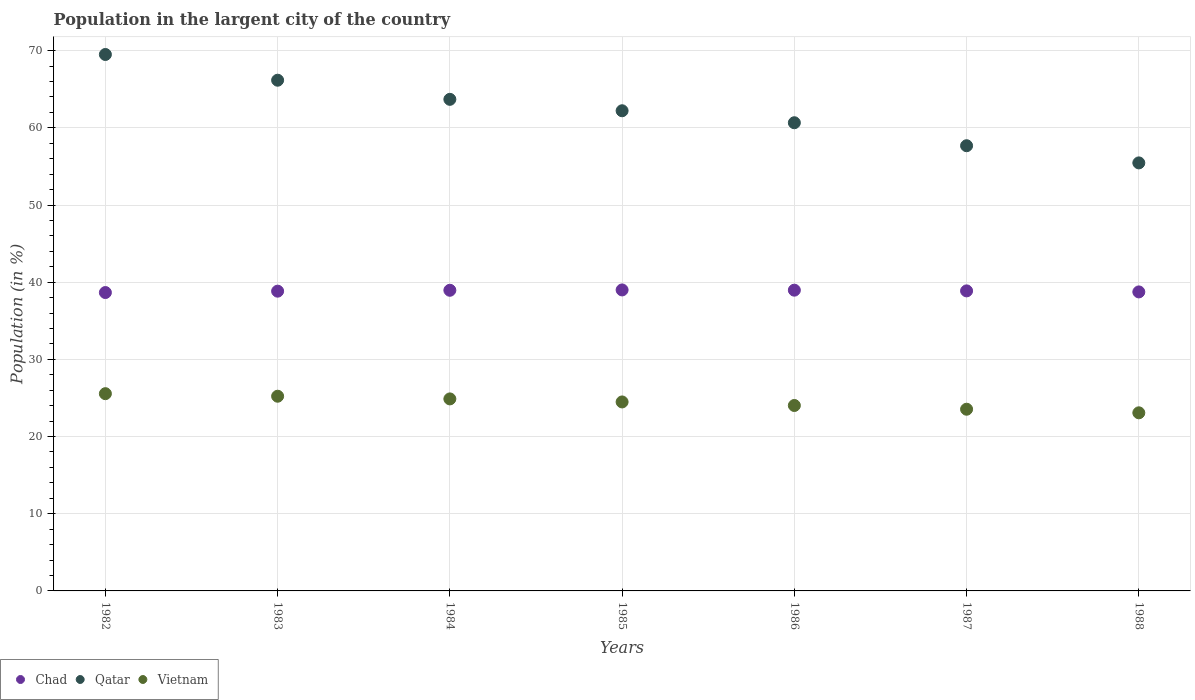Is the number of dotlines equal to the number of legend labels?
Your answer should be very brief. Yes. What is the percentage of population in the largent city in Chad in 1982?
Provide a succinct answer. 38.66. Across all years, what is the maximum percentage of population in the largent city in Vietnam?
Give a very brief answer. 25.56. Across all years, what is the minimum percentage of population in the largent city in Vietnam?
Your response must be concise. 23.08. In which year was the percentage of population in the largent city in Qatar minimum?
Offer a very short reply. 1988. What is the total percentage of population in the largent city in Chad in the graph?
Your response must be concise. 272.04. What is the difference between the percentage of population in the largent city in Qatar in 1983 and that in 1984?
Provide a succinct answer. 2.48. What is the difference between the percentage of population in the largent city in Vietnam in 1984 and the percentage of population in the largent city in Qatar in 1987?
Offer a very short reply. -32.8. What is the average percentage of population in the largent city in Chad per year?
Provide a short and direct response. 38.86. In the year 1986, what is the difference between the percentage of population in the largent city in Vietnam and percentage of population in the largent city in Qatar?
Provide a succinct answer. -36.63. What is the ratio of the percentage of population in the largent city in Vietnam in 1983 to that in 1986?
Offer a terse response. 1.05. Is the difference between the percentage of population in the largent city in Vietnam in 1985 and 1986 greater than the difference between the percentage of population in the largent city in Qatar in 1985 and 1986?
Provide a short and direct response. No. What is the difference between the highest and the second highest percentage of population in the largent city in Vietnam?
Keep it short and to the point. 0.33. What is the difference between the highest and the lowest percentage of population in the largent city in Chad?
Give a very brief answer. 0.34. Is the sum of the percentage of population in the largent city in Chad in 1985 and 1987 greater than the maximum percentage of population in the largent city in Qatar across all years?
Give a very brief answer. Yes. Is it the case that in every year, the sum of the percentage of population in the largent city in Vietnam and percentage of population in the largent city in Chad  is greater than the percentage of population in the largent city in Qatar?
Keep it short and to the point. No. Is the percentage of population in the largent city in Qatar strictly greater than the percentage of population in the largent city in Vietnam over the years?
Provide a succinct answer. Yes. How many years are there in the graph?
Your response must be concise. 7. What is the difference between two consecutive major ticks on the Y-axis?
Offer a very short reply. 10. Are the values on the major ticks of Y-axis written in scientific E-notation?
Provide a short and direct response. No. Does the graph contain any zero values?
Offer a terse response. No. Does the graph contain grids?
Keep it short and to the point. Yes. What is the title of the graph?
Keep it short and to the point. Population in the largent city of the country. What is the label or title of the X-axis?
Give a very brief answer. Years. What is the Population (in %) of Chad in 1982?
Your answer should be very brief. 38.66. What is the Population (in %) in Qatar in 1982?
Provide a succinct answer. 69.5. What is the Population (in %) in Vietnam in 1982?
Your answer should be compact. 25.56. What is the Population (in %) in Chad in 1983?
Offer a very short reply. 38.84. What is the Population (in %) in Qatar in 1983?
Your response must be concise. 66.17. What is the Population (in %) of Vietnam in 1983?
Make the answer very short. 25.23. What is the Population (in %) of Chad in 1984?
Keep it short and to the point. 38.95. What is the Population (in %) of Qatar in 1984?
Provide a short and direct response. 63.69. What is the Population (in %) in Vietnam in 1984?
Offer a very short reply. 24.88. What is the Population (in %) in Chad in 1985?
Give a very brief answer. 39. What is the Population (in %) of Qatar in 1985?
Provide a succinct answer. 62.21. What is the Population (in %) in Vietnam in 1985?
Keep it short and to the point. 24.49. What is the Population (in %) of Chad in 1986?
Your response must be concise. 38.97. What is the Population (in %) in Qatar in 1986?
Your response must be concise. 60.66. What is the Population (in %) in Vietnam in 1986?
Ensure brevity in your answer.  24.03. What is the Population (in %) of Chad in 1987?
Your answer should be compact. 38.87. What is the Population (in %) in Qatar in 1987?
Ensure brevity in your answer.  57.68. What is the Population (in %) in Vietnam in 1987?
Make the answer very short. 23.54. What is the Population (in %) in Chad in 1988?
Your answer should be very brief. 38.74. What is the Population (in %) of Qatar in 1988?
Ensure brevity in your answer.  55.46. What is the Population (in %) in Vietnam in 1988?
Give a very brief answer. 23.08. Across all years, what is the maximum Population (in %) of Chad?
Provide a short and direct response. 39. Across all years, what is the maximum Population (in %) in Qatar?
Give a very brief answer. 69.5. Across all years, what is the maximum Population (in %) of Vietnam?
Keep it short and to the point. 25.56. Across all years, what is the minimum Population (in %) of Chad?
Ensure brevity in your answer.  38.66. Across all years, what is the minimum Population (in %) in Qatar?
Make the answer very short. 55.46. Across all years, what is the minimum Population (in %) in Vietnam?
Ensure brevity in your answer.  23.08. What is the total Population (in %) of Chad in the graph?
Ensure brevity in your answer.  272.04. What is the total Population (in %) of Qatar in the graph?
Offer a terse response. 435.38. What is the total Population (in %) in Vietnam in the graph?
Your answer should be very brief. 170.79. What is the difference between the Population (in %) in Chad in 1982 and that in 1983?
Ensure brevity in your answer.  -0.18. What is the difference between the Population (in %) in Qatar in 1982 and that in 1983?
Offer a very short reply. 3.33. What is the difference between the Population (in %) of Vietnam in 1982 and that in 1983?
Make the answer very short. 0.33. What is the difference between the Population (in %) of Chad in 1982 and that in 1984?
Offer a very short reply. -0.29. What is the difference between the Population (in %) of Qatar in 1982 and that in 1984?
Make the answer very short. 5.81. What is the difference between the Population (in %) in Vietnam in 1982 and that in 1984?
Ensure brevity in your answer.  0.68. What is the difference between the Population (in %) of Chad in 1982 and that in 1985?
Keep it short and to the point. -0.34. What is the difference between the Population (in %) in Qatar in 1982 and that in 1985?
Ensure brevity in your answer.  7.29. What is the difference between the Population (in %) of Vietnam in 1982 and that in 1985?
Offer a terse response. 1.07. What is the difference between the Population (in %) of Chad in 1982 and that in 1986?
Offer a terse response. -0.31. What is the difference between the Population (in %) in Qatar in 1982 and that in 1986?
Your response must be concise. 8.84. What is the difference between the Population (in %) of Vietnam in 1982 and that in 1986?
Your answer should be very brief. 1.53. What is the difference between the Population (in %) of Chad in 1982 and that in 1987?
Provide a succinct answer. -0.22. What is the difference between the Population (in %) in Qatar in 1982 and that in 1987?
Provide a succinct answer. 11.82. What is the difference between the Population (in %) of Vietnam in 1982 and that in 1987?
Ensure brevity in your answer.  2.01. What is the difference between the Population (in %) in Chad in 1982 and that in 1988?
Provide a succinct answer. -0.08. What is the difference between the Population (in %) in Qatar in 1982 and that in 1988?
Provide a succinct answer. 14.05. What is the difference between the Population (in %) in Vietnam in 1982 and that in 1988?
Your response must be concise. 2.48. What is the difference between the Population (in %) in Chad in 1983 and that in 1984?
Offer a terse response. -0.12. What is the difference between the Population (in %) of Qatar in 1983 and that in 1984?
Offer a very short reply. 2.48. What is the difference between the Population (in %) of Vietnam in 1983 and that in 1984?
Your response must be concise. 0.35. What is the difference between the Population (in %) in Chad in 1983 and that in 1985?
Your answer should be compact. -0.16. What is the difference between the Population (in %) of Qatar in 1983 and that in 1985?
Keep it short and to the point. 3.96. What is the difference between the Population (in %) of Vietnam in 1983 and that in 1985?
Ensure brevity in your answer.  0.74. What is the difference between the Population (in %) of Chad in 1983 and that in 1986?
Provide a short and direct response. -0.13. What is the difference between the Population (in %) of Qatar in 1983 and that in 1986?
Your answer should be compact. 5.51. What is the difference between the Population (in %) of Vietnam in 1983 and that in 1986?
Offer a very short reply. 1.2. What is the difference between the Population (in %) in Chad in 1983 and that in 1987?
Provide a short and direct response. -0.04. What is the difference between the Population (in %) in Qatar in 1983 and that in 1987?
Your answer should be very brief. 8.49. What is the difference between the Population (in %) in Vietnam in 1983 and that in 1987?
Your response must be concise. 1.68. What is the difference between the Population (in %) of Chad in 1983 and that in 1988?
Your answer should be very brief. 0.1. What is the difference between the Population (in %) of Qatar in 1983 and that in 1988?
Provide a short and direct response. 10.71. What is the difference between the Population (in %) in Vietnam in 1983 and that in 1988?
Provide a short and direct response. 2.15. What is the difference between the Population (in %) in Chad in 1984 and that in 1985?
Your answer should be compact. -0.04. What is the difference between the Population (in %) in Qatar in 1984 and that in 1985?
Ensure brevity in your answer.  1.48. What is the difference between the Population (in %) of Vietnam in 1984 and that in 1985?
Your answer should be compact. 0.39. What is the difference between the Population (in %) in Chad in 1984 and that in 1986?
Your answer should be very brief. -0.01. What is the difference between the Population (in %) of Qatar in 1984 and that in 1986?
Offer a very short reply. 3.03. What is the difference between the Population (in %) in Vietnam in 1984 and that in 1986?
Offer a terse response. 0.85. What is the difference between the Population (in %) in Chad in 1984 and that in 1987?
Offer a very short reply. 0.08. What is the difference between the Population (in %) of Qatar in 1984 and that in 1987?
Give a very brief answer. 6.01. What is the difference between the Population (in %) in Vietnam in 1984 and that in 1987?
Keep it short and to the point. 1.34. What is the difference between the Population (in %) in Chad in 1984 and that in 1988?
Provide a short and direct response. 0.21. What is the difference between the Population (in %) of Qatar in 1984 and that in 1988?
Your answer should be very brief. 8.23. What is the difference between the Population (in %) in Vietnam in 1984 and that in 1988?
Ensure brevity in your answer.  1.8. What is the difference between the Population (in %) of Chad in 1985 and that in 1986?
Keep it short and to the point. 0.03. What is the difference between the Population (in %) in Qatar in 1985 and that in 1986?
Offer a terse response. 1.55. What is the difference between the Population (in %) of Vietnam in 1985 and that in 1986?
Your answer should be compact. 0.46. What is the difference between the Population (in %) of Chad in 1985 and that in 1987?
Give a very brief answer. 0.12. What is the difference between the Population (in %) of Qatar in 1985 and that in 1987?
Provide a short and direct response. 4.53. What is the difference between the Population (in %) of Vietnam in 1985 and that in 1987?
Give a very brief answer. 0.94. What is the difference between the Population (in %) of Chad in 1985 and that in 1988?
Ensure brevity in your answer.  0.26. What is the difference between the Population (in %) in Qatar in 1985 and that in 1988?
Your answer should be very brief. 6.75. What is the difference between the Population (in %) in Vietnam in 1985 and that in 1988?
Your answer should be compact. 1.41. What is the difference between the Population (in %) of Chad in 1986 and that in 1987?
Provide a succinct answer. 0.09. What is the difference between the Population (in %) in Qatar in 1986 and that in 1987?
Ensure brevity in your answer.  2.98. What is the difference between the Population (in %) in Vietnam in 1986 and that in 1987?
Offer a very short reply. 0.48. What is the difference between the Population (in %) of Chad in 1986 and that in 1988?
Offer a terse response. 0.23. What is the difference between the Population (in %) in Qatar in 1986 and that in 1988?
Your answer should be very brief. 5.2. What is the difference between the Population (in %) of Vietnam in 1986 and that in 1988?
Offer a terse response. 0.95. What is the difference between the Population (in %) in Chad in 1987 and that in 1988?
Provide a succinct answer. 0.13. What is the difference between the Population (in %) in Qatar in 1987 and that in 1988?
Your response must be concise. 2.22. What is the difference between the Population (in %) in Vietnam in 1987 and that in 1988?
Your response must be concise. 0.47. What is the difference between the Population (in %) of Chad in 1982 and the Population (in %) of Qatar in 1983?
Provide a succinct answer. -27.51. What is the difference between the Population (in %) in Chad in 1982 and the Population (in %) in Vietnam in 1983?
Give a very brief answer. 13.43. What is the difference between the Population (in %) in Qatar in 1982 and the Population (in %) in Vietnam in 1983?
Provide a succinct answer. 44.28. What is the difference between the Population (in %) of Chad in 1982 and the Population (in %) of Qatar in 1984?
Your answer should be compact. -25.03. What is the difference between the Population (in %) of Chad in 1982 and the Population (in %) of Vietnam in 1984?
Your response must be concise. 13.78. What is the difference between the Population (in %) of Qatar in 1982 and the Population (in %) of Vietnam in 1984?
Provide a short and direct response. 44.62. What is the difference between the Population (in %) in Chad in 1982 and the Population (in %) in Qatar in 1985?
Offer a very short reply. -23.55. What is the difference between the Population (in %) of Chad in 1982 and the Population (in %) of Vietnam in 1985?
Keep it short and to the point. 14.17. What is the difference between the Population (in %) of Qatar in 1982 and the Population (in %) of Vietnam in 1985?
Provide a short and direct response. 45.02. What is the difference between the Population (in %) in Chad in 1982 and the Population (in %) in Qatar in 1986?
Keep it short and to the point. -22. What is the difference between the Population (in %) of Chad in 1982 and the Population (in %) of Vietnam in 1986?
Offer a very short reply. 14.63. What is the difference between the Population (in %) of Qatar in 1982 and the Population (in %) of Vietnam in 1986?
Make the answer very short. 45.48. What is the difference between the Population (in %) in Chad in 1982 and the Population (in %) in Qatar in 1987?
Make the answer very short. -19.02. What is the difference between the Population (in %) in Chad in 1982 and the Population (in %) in Vietnam in 1987?
Provide a short and direct response. 15.12. What is the difference between the Population (in %) of Qatar in 1982 and the Population (in %) of Vietnam in 1987?
Provide a short and direct response. 45.96. What is the difference between the Population (in %) in Chad in 1982 and the Population (in %) in Qatar in 1988?
Provide a short and direct response. -16.8. What is the difference between the Population (in %) in Chad in 1982 and the Population (in %) in Vietnam in 1988?
Offer a terse response. 15.58. What is the difference between the Population (in %) in Qatar in 1982 and the Population (in %) in Vietnam in 1988?
Your response must be concise. 46.43. What is the difference between the Population (in %) of Chad in 1983 and the Population (in %) of Qatar in 1984?
Offer a terse response. -24.85. What is the difference between the Population (in %) in Chad in 1983 and the Population (in %) in Vietnam in 1984?
Your answer should be very brief. 13.96. What is the difference between the Population (in %) in Qatar in 1983 and the Population (in %) in Vietnam in 1984?
Offer a terse response. 41.29. What is the difference between the Population (in %) of Chad in 1983 and the Population (in %) of Qatar in 1985?
Offer a terse response. -23.37. What is the difference between the Population (in %) in Chad in 1983 and the Population (in %) in Vietnam in 1985?
Make the answer very short. 14.35. What is the difference between the Population (in %) in Qatar in 1983 and the Population (in %) in Vietnam in 1985?
Provide a short and direct response. 41.68. What is the difference between the Population (in %) in Chad in 1983 and the Population (in %) in Qatar in 1986?
Offer a terse response. -21.82. What is the difference between the Population (in %) of Chad in 1983 and the Population (in %) of Vietnam in 1986?
Your answer should be compact. 14.81. What is the difference between the Population (in %) in Qatar in 1983 and the Population (in %) in Vietnam in 1986?
Provide a succinct answer. 42.14. What is the difference between the Population (in %) of Chad in 1983 and the Population (in %) of Qatar in 1987?
Your answer should be compact. -18.84. What is the difference between the Population (in %) of Chad in 1983 and the Population (in %) of Vietnam in 1987?
Provide a succinct answer. 15.3. What is the difference between the Population (in %) of Qatar in 1983 and the Population (in %) of Vietnam in 1987?
Provide a short and direct response. 42.63. What is the difference between the Population (in %) of Chad in 1983 and the Population (in %) of Qatar in 1988?
Offer a terse response. -16.62. What is the difference between the Population (in %) of Chad in 1983 and the Population (in %) of Vietnam in 1988?
Offer a terse response. 15.76. What is the difference between the Population (in %) in Qatar in 1983 and the Population (in %) in Vietnam in 1988?
Provide a succinct answer. 43.09. What is the difference between the Population (in %) in Chad in 1984 and the Population (in %) in Qatar in 1985?
Your response must be concise. -23.26. What is the difference between the Population (in %) of Chad in 1984 and the Population (in %) of Vietnam in 1985?
Offer a very short reply. 14.47. What is the difference between the Population (in %) in Qatar in 1984 and the Population (in %) in Vietnam in 1985?
Provide a succinct answer. 39.21. What is the difference between the Population (in %) in Chad in 1984 and the Population (in %) in Qatar in 1986?
Your answer should be compact. -21.71. What is the difference between the Population (in %) in Chad in 1984 and the Population (in %) in Vietnam in 1986?
Your response must be concise. 14.93. What is the difference between the Population (in %) of Qatar in 1984 and the Population (in %) of Vietnam in 1986?
Your answer should be compact. 39.67. What is the difference between the Population (in %) of Chad in 1984 and the Population (in %) of Qatar in 1987?
Your response must be concise. -18.73. What is the difference between the Population (in %) in Chad in 1984 and the Population (in %) in Vietnam in 1987?
Offer a very short reply. 15.41. What is the difference between the Population (in %) in Qatar in 1984 and the Population (in %) in Vietnam in 1987?
Your answer should be very brief. 40.15. What is the difference between the Population (in %) of Chad in 1984 and the Population (in %) of Qatar in 1988?
Your answer should be compact. -16.5. What is the difference between the Population (in %) of Chad in 1984 and the Population (in %) of Vietnam in 1988?
Provide a succinct answer. 15.88. What is the difference between the Population (in %) of Qatar in 1984 and the Population (in %) of Vietnam in 1988?
Keep it short and to the point. 40.62. What is the difference between the Population (in %) in Chad in 1985 and the Population (in %) in Qatar in 1986?
Your answer should be compact. -21.66. What is the difference between the Population (in %) of Chad in 1985 and the Population (in %) of Vietnam in 1986?
Your answer should be very brief. 14.97. What is the difference between the Population (in %) in Qatar in 1985 and the Population (in %) in Vietnam in 1986?
Ensure brevity in your answer.  38.19. What is the difference between the Population (in %) in Chad in 1985 and the Population (in %) in Qatar in 1987?
Keep it short and to the point. -18.68. What is the difference between the Population (in %) of Chad in 1985 and the Population (in %) of Vietnam in 1987?
Offer a very short reply. 15.46. What is the difference between the Population (in %) in Qatar in 1985 and the Population (in %) in Vietnam in 1987?
Your answer should be very brief. 38.67. What is the difference between the Population (in %) of Chad in 1985 and the Population (in %) of Qatar in 1988?
Provide a succinct answer. -16.46. What is the difference between the Population (in %) of Chad in 1985 and the Population (in %) of Vietnam in 1988?
Provide a succinct answer. 15.92. What is the difference between the Population (in %) in Qatar in 1985 and the Population (in %) in Vietnam in 1988?
Provide a short and direct response. 39.14. What is the difference between the Population (in %) in Chad in 1986 and the Population (in %) in Qatar in 1987?
Provide a succinct answer. -18.71. What is the difference between the Population (in %) of Chad in 1986 and the Population (in %) of Vietnam in 1987?
Your response must be concise. 15.43. What is the difference between the Population (in %) in Qatar in 1986 and the Population (in %) in Vietnam in 1987?
Make the answer very short. 37.12. What is the difference between the Population (in %) of Chad in 1986 and the Population (in %) of Qatar in 1988?
Give a very brief answer. -16.49. What is the difference between the Population (in %) in Chad in 1986 and the Population (in %) in Vietnam in 1988?
Your answer should be very brief. 15.89. What is the difference between the Population (in %) of Qatar in 1986 and the Population (in %) of Vietnam in 1988?
Your response must be concise. 37.58. What is the difference between the Population (in %) of Chad in 1987 and the Population (in %) of Qatar in 1988?
Make the answer very short. -16.58. What is the difference between the Population (in %) in Chad in 1987 and the Population (in %) in Vietnam in 1988?
Make the answer very short. 15.8. What is the difference between the Population (in %) in Qatar in 1987 and the Population (in %) in Vietnam in 1988?
Give a very brief answer. 34.61. What is the average Population (in %) of Chad per year?
Make the answer very short. 38.86. What is the average Population (in %) in Qatar per year?
Offer a very short reply. 62.2. What is the average Population (in %) in Vietnam per year?
Make the answer very short. 24.4. In the year 1982, what is the difference between the Population (in %) of Chad and Population (in %) of Qatar?
Your response must be concise. -30.84. In the year 1982, what is the difference between the Population (in %) of Chad and Population (in %) of Vietnam?
Your response must be concise. 13.1. In the year 1982, what is the difference between the Population (in %) in Qatar and Population (in %) in Vietnam?
Keep it short and to the point. 43.95. In the year 1983, what is the difference between the Population (in %) in Chad and Population (in %) in Qatar?
Your response must be concise. -27.33. In the year 1983, what is the difference between the Population (in %) of Chad and Population (in %) of Vietnam?
Make the answer very short. 13.61. In the year 1983, what is the difference between the Population (in %) of Qatar and Population (in %) of Vietnam?
Offer a very short reply. 40.94. In the year 1984, what is the difference between the Population (in %) of Chad and Population (in %) of Qatar?
Ensure brevity in your answer.  -24.74. In the year 1984, what is the difference between the Population (in %) of Chad and Population (in %) of Vietnam?
Give a very brief answer. 14.08. In the year 1984, what is the difference between the Population (in %) in Qatar and Population (in %) in Vietnam?
Offer a terse response. 38.81. In the year 1985, what is the difference between the Population (in %) of Chad and Population (in %) of Qatar?
Ensure brevity in your answer.  -23.21. In the year 1985, what is the difference between the Population (in %) of Chad and Population (in %) of Vietnam?
Ensure brevity in your answer.  14.51. In the year 1985, what is the difference between the Population (in %) of Qatar and Population (in %) of Vietnam?
Ensure brevity in your answer.  37.73. In the year 1986, what is the difference between the Population (in %) of Chad and Population (in %) of Qatar?
Give a very brief answer. -21.69. In the year 1986, what is the difference between the Population (in %) of Chad and Population (in %) of Vietnam?
Provide a succinct answer. 14.94. In the year 1986, what is the difference between the Population (in %) of Qatar and Population (in %) of Vietnam?
Your answer should be very brief. 36.63. In the year 1987, what is the difference between the Population (in %) in Chad and Population (in %) in Qatar?
Your answer should be very brief. -18.81. In the year 1987, what is the difference between the Population (in %) in Chad and Population (in %) in Vietnam?
Your response must be concise. 15.33. In the year 1987, what is the difference between the Population (in %) of Qatar and Population (in %) of Vietnam?
Provide a succinct answer. 34.14. In the year 1988, what is the difference between the Population (in %) of Chad and Population (in %) of Qatar?
Offer a terse response. -16.72. In the year 1988, what is the difference between the Population (in %) in Chad and Population (in %) in Vietnam?
Offer a terse response. 15.67. In the year 1988, what is the difference between the Population (in %) in Qatar and Population (in %) in Vietnam?
Ensure brevity in your answer.  32.38. What is the ratio of the Population (in %) in Qatar in 1982 to that in 1983?
Offer a very short reply. 1.05. What is the ratio of the Population (in %) in Vietnam in 1982 to that in 1983?
Keep it short and to the point. 1.01. What is the ratio of the Population (in %) in Chad in 1982 to that in 1984?
Make the answer very short. 0.99. What is the ratio of the Population (in %) in Qatar in 1982 to that in 1984?
Your answer should be very brief. 1.09. What is the ratio of the Population (in %) in Vietnam in 1982 to that in 1984?
Ensure brevity in your answer.  1.03. What is the ratio of the Population (in %) of Qatar in 1982 to that in 1985?
Your answer should be compact. 1.12. What is the ratio of the Population (in %) of Vietnam in 1982 to that in 1985?
Ensure brevity in your answer.  1.04. What is the ratio of the Population (in %) of Chad in 1982 to that in 1986?
Ensure brevity in your answer.  0.99. What is the ratio of the Population (in %) of Qatar in 1982 to that in 1986?
Make the answer very short. 1.15. What is the ratio of the Population (in %) of Vietnam in 1982 to that in 1986?
Your answer should be compact. 1.06. What is the ratio of the Population (in %) of Qatar in 1982 to that in 1987?
Your response must be concise. 1.2. What is the ratio of the Population (in %) in Vietnam in 1982 to that in 1987?
Offer a very short reply. 1.09. What is the ratio of the Population (in %) of Qatar in 1982 to that in 1988?
Ensure brevity in your answer.  1.25. What is the ratio of the Population (in %) in Vietnam in 1982 to that in 1988?
Your response must be concise. 1.11. What is the ratio of the Population (in %) of Chad in 1983 to that in 1984?
Offer a terse response. 1. What is the ratio of the Population (in %) in Qatar in 1983 to that in 1984?
Ensure brevity in your answer.  1.04. What is the ratio of the Population (in %) of Vietnam in 1983 to that in 1984?
Keep it short and to the point. 1.01. What is the ratio of the Population (in %) of Chad in 1983 to that in 1985?
Provide a short and direct response. 1. What is the ratio of the Population (in %) of Qatar in 1983 to that in 1985?
Provide a short and direct response. 1.06. What is the ratio of the Population (in %) of Vietnam in 1983 to that in 1985?
Make the answer very short. 1.03. What is the ratio of the Population (in %) of Chad in 1983 to that in 1986?
Keep it short and to the point. 1. What is the ratio of the Population (in %) in Qatar in 1983 to that in 1986?
Ensure brevity in your answer.  1.09. What is the ratio of the Population (in %) in Vietnam in 1983 to that in 1986?
Provide a succinct answer. 1.05. What is the ratio of the Population (in %) of Chad in 1983 to that in 1987?
Offer a very short reply. 1. What is the ratio of the Population (in %) in Qatar in 1983 to that in 1987?
Ensure brevity in your answer.  1.15. What is the ratio of the Population (in %) in Vietnam in 1983 to that in 1987?
Offer a terse response. 1.07. What is the ratio of the Population (in %) in Qatar in 1983 to that in 1988?
Your answer should be very brief. 1.19. What is the ratio of the Population (in %) of Vietnam in 1983 to that in 1988?
Your response must be concise. 1.09. What is the ratio of the Population (in %) in Qatar in 1984 to that in 1985?
Offer a very short reply. 1.02. What is the ratio of the Population (in %) of Vietnam in 1984 to that in 1985?
Your answer should be very brief. 1.02. What is the ratio of the Population (in %) of Chad in 1984 to that in 1986?
Provide a succinct answer. 1. What is the ratio of the Population (in %) in Qatar in 1984 to that in 1986?
Your answer should be compact. 1.05. What is the ratio of the Population (in %) in Vietnam in 1984 to that in 1986?
Offer a terse response. 1.04. What is the ratio of the Population (in %) of Chad in 1984 to that in 1987?
Offer a very short reply. 1. What is the ratio of the Population (in %) of Qatar in 1984 to that in 1987?
Offer a terse response. 1.1. What is the ratio of the Population (in %) in Vietnam in 1984 to that in 1987?
Ensure brevity in your answer.  1.06. What is the ratio of the Population (in %) in Qatar in 1984 to that in 1988?
Ensure brevity in your answer.  1.15. What is the ratio of the Population (in %) of Vietnam in 1984 to that in 1988?
Provide a short and direct response. 1.08. What is the ratio of the Population (in %) in Qatar in 1985 to that in 1986?
Give a very brief answer. 1.03. What is the ratio of the Population (in %) of Vietnam in 1985 to that in 1986?
Your answer should be compact. 1.02. What is the ratio of the Population (in %) of Chad in 1985 to that in 1987?
Give a very brief answer. 1. What is the ratio of the Population (in %) of Qatar in 1985 to that in 1987?
Give a very brief answer. 1.08. What is the ratio of the Population (in %) in Vietnam in 1985 to that in 1987?
Ensure brevity in your answer.  1.04. What is the ratio of the Population (in %) of Chad in 1985 to that in 1988?
Keep it short and to the point. 1.01. What is the ratio of the Population (in %) of Qatar in 1985 to that in 1988?
Provide a short and direct response. 1.12. What is the ratio of the Population (in %) of Vietnam in 1985 to that in 1988?
Provide a short and direct response. 1.06. What is the ratio of the Population (in %) of Chad in 1986 to that in 1987?
Your response must be concise. 1. What is the ratio of the Population (in %) of Qatar in 1986 to that in 1987?
Keep it short and to the point. 1.05. What is the ratio of the Population (in %) in Vietnam in 1986 to that in 1987?
Keep it short and to the point. 1.02. What is the ratio of the Population (in %) of Qatar in 1986 to that in 1988?
Give a very brief answer. 1.09. What is the ratio of the Population (in %) in Vietnam in 1986 to that in 1988?
Keep it short and to the point. 1.04. What is the ratio of the Population (in %) in Chad in 1987 to that in 1988?
Provide a succinct answer. 1. What is the ratio of the Population (in %) in Qatar in 1987 to that in 1988?
Offer a terse response. 1.04. What is the ratio of the Population (in %) in Vietnam in 1987 to that in 1988?
Offer a terse response. 1.02. What is the difference between the highest and the second highest Population (in %) in Chad?
Your response must be concise. 0.03. What is the difference between the highest and the second highest Population (in %) of Vietnam?
Provide a short and direct response. 0.33. What is the difference between the highest and the lowest Population (in %) in Chad?
Offer a very short reply. 0.34. What is the difference between the highest and the lowest Population (in %) in Qatar?
Ensure brevity in your answer.  14.05. What is the difference between the highest and the lowest Population (in %) in Vietnam?
Offer a very short reply. 2.48. 